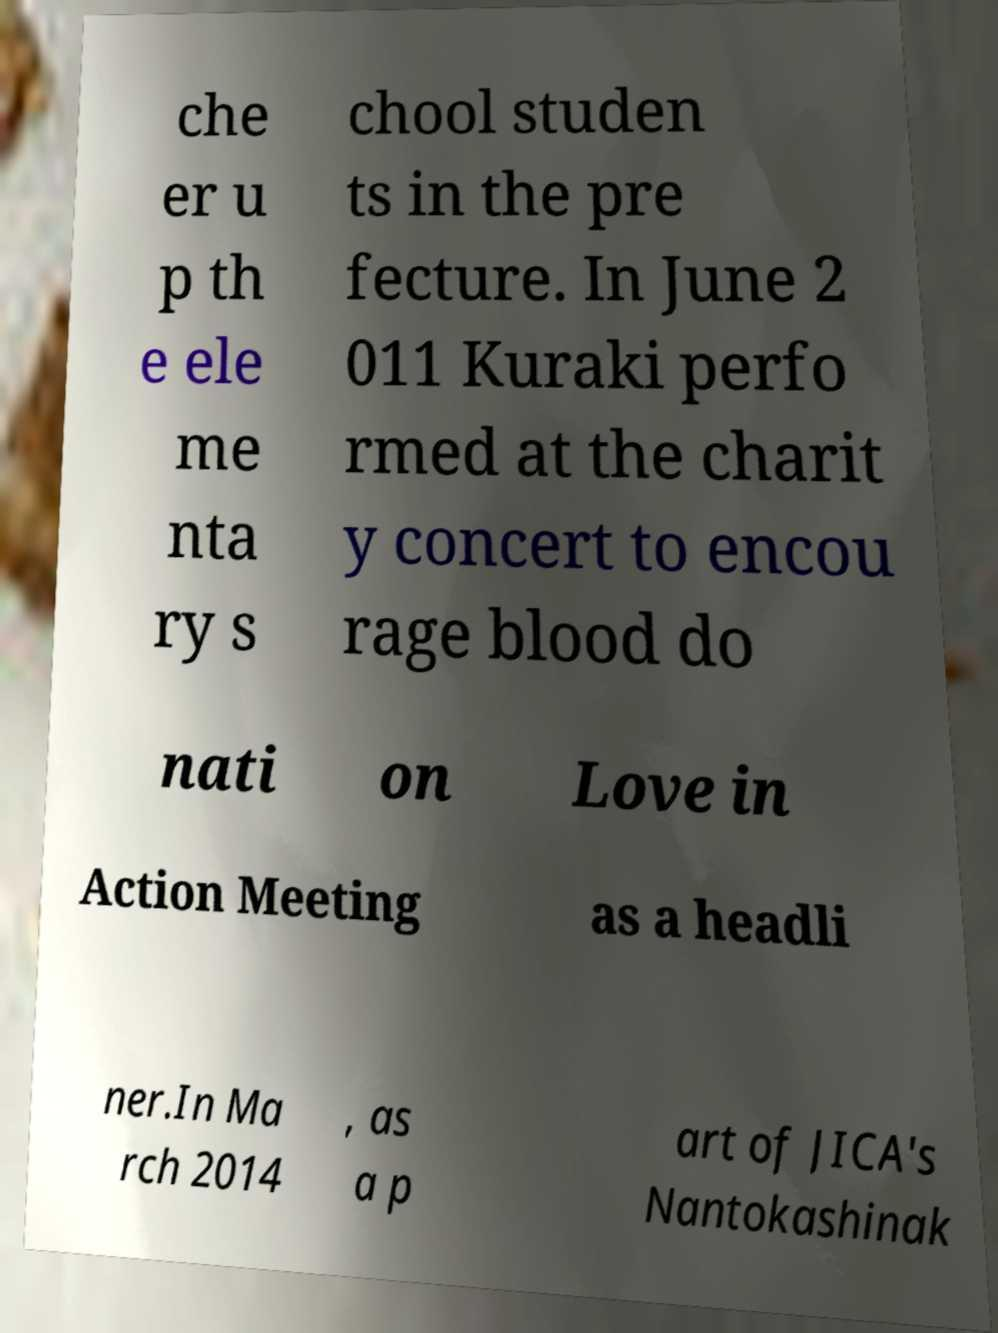Please identify and transcribe the text found in this image. che er u p th e ele me nta ry s chool studen ts in the pre fecture. In June 2 011 Kuraki perfo rmed at the charit y concert to encou rage blood do nati on Love in Action Meeting as a headli ner.In Ma rch 2014 , as a p art of JICA's Nantokashinak 